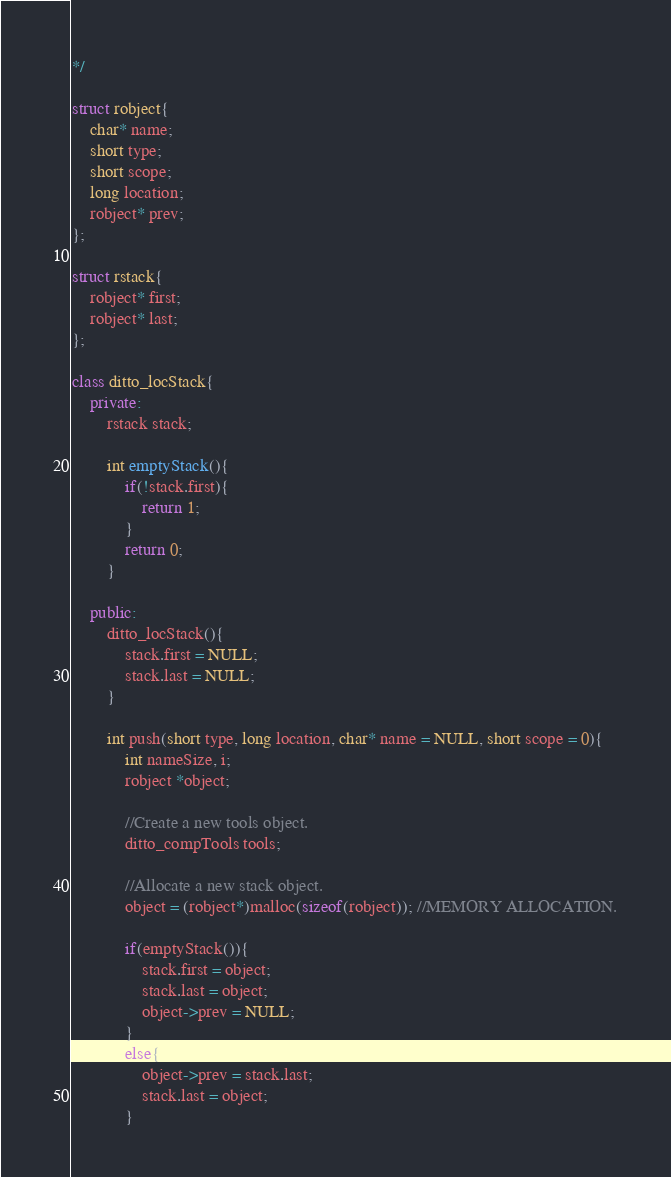Convert code to text. <code><loc_0><loc_0><loc_500><loc_500><_C++_>*/

struct robject{
	char* name;
	short type;
	short scope;
	long location;
	robject* prev;
};

struct rstack{
	robject* first;
	robject* last;
};

class ditto_locStack{
	private:
		rstack stack;

		int emptyStack(){
			if(!stack.first){
				return 1;
			}
			return 0;
		}

	public:
		ditto_locStack(){
			stack.first = NULL;
			stack.last = NULL;
		}

		int push(short type, long location, char* name = NULL, short scope = 0){
			int nameSize, i;
			robject *object;

			//Create a new tools object.
			ditto_compTools tools;

			//Allocate a new stack object.
			object = (robject*)malloc(sizeof(robject)); //MEMORY ALLOCATION.

			if(emptyStack()){
				stack.first = object;
				stack.last = object;
				object->prev = NULL;
			}
			else{
				object->prev = stack.last;
				stack.last = object;
			}
</code> 